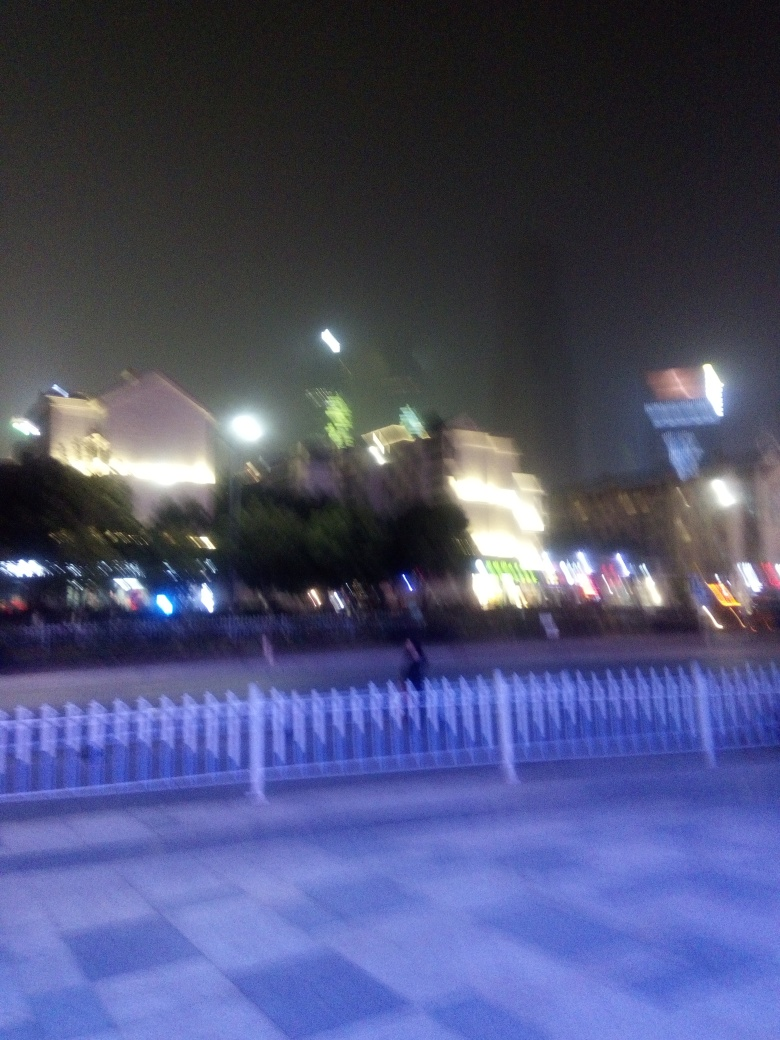Describe the lighting in this image. What does it tell us about the location and time? The image features artificial lighting, which is prominent against the night sky, indicating it was taken after sunset. The variety of light colors suggests a diversity of establishments, which often signifies a lively urban setting. The absence of natural light can imply it's a location that relies on nightlife and human activity for vibrancy. 